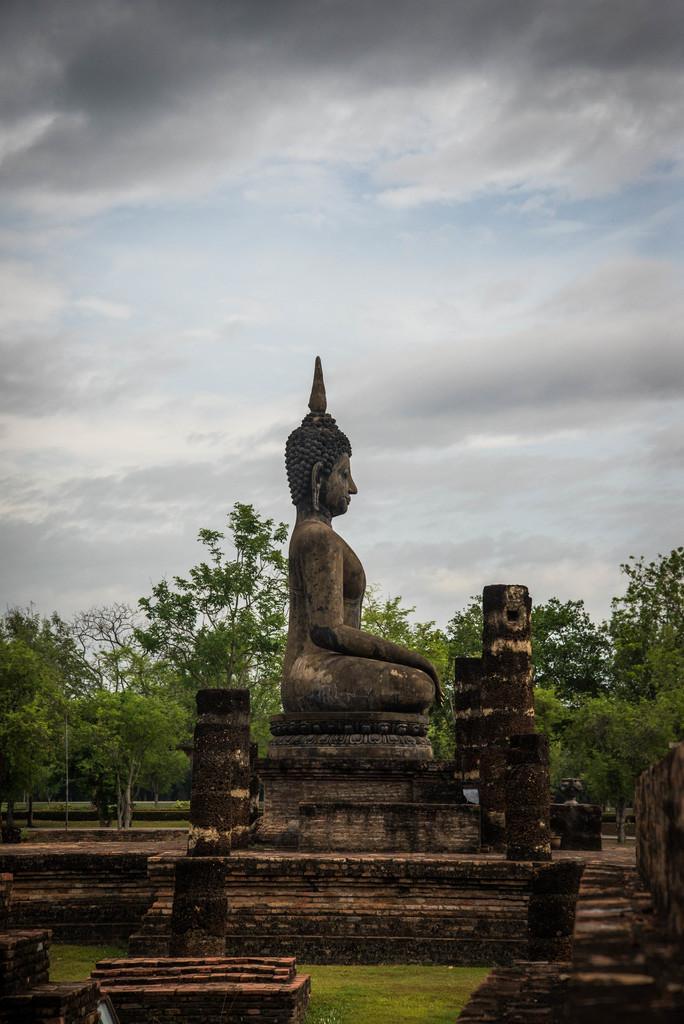How would you summarize this image in a sentence or two? At the center of the image there is a statue. In the background there are trees and a sky. 